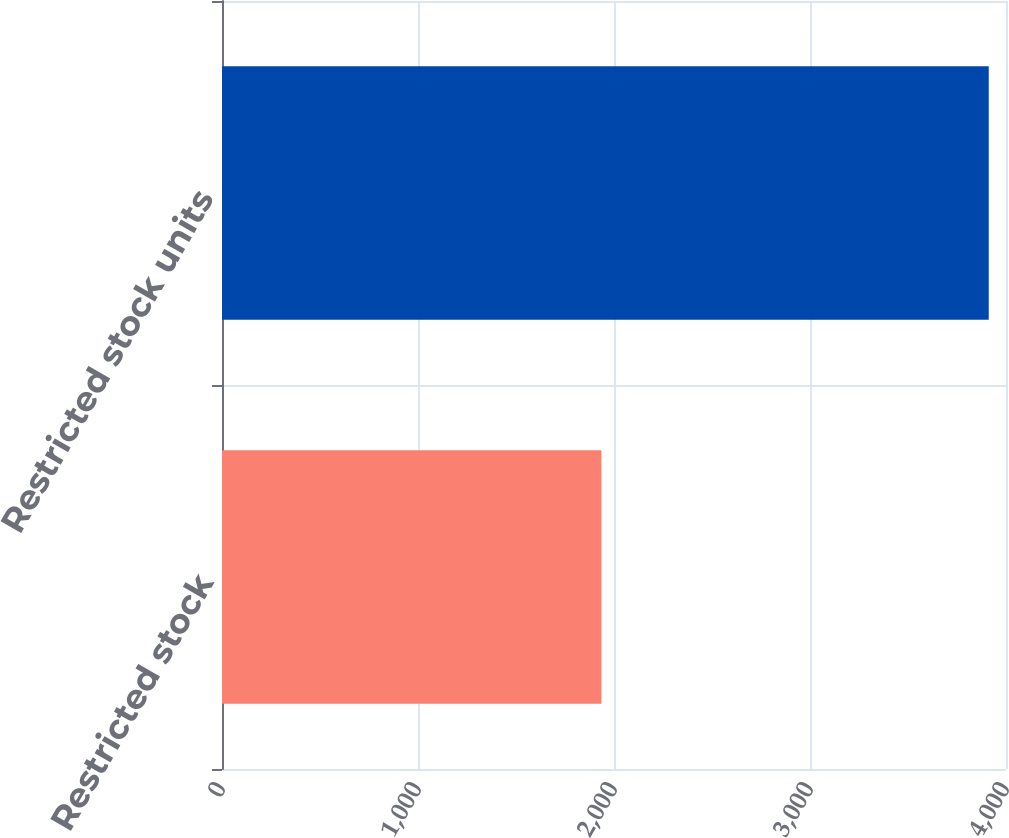Convert chart to OTSL. <chart><loc_0><loc_0><loc_500><loc_500><bar_chart><fcel>Restricted stock<fcel>Restricted stock units<nl><fcel>1936<fcel>3912<nl></chart> 